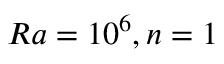Convert formula to latex. <formula><loc_0><loc_0><loc_500><loc_500>R a = 1 0 ^ { 6 } , n = 1</formula> 